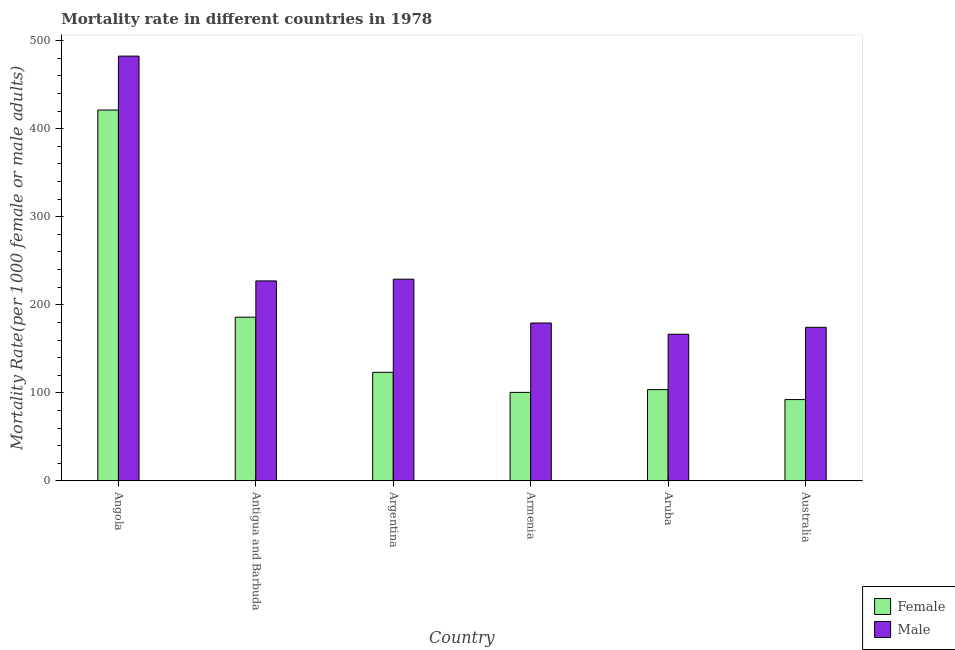Are the number of bars per tick equal to the number of legend labels?
Your response must be concise. Yes. What is the label of the 4th group of bars from the left?
Your response must be concise. Armenia. What is the female mortality rate in Argentina?
Offer a terse response. 123.38. Across all countries, what is the maximum female mortality rate?
Your answer should be compact. 421.19. Across all countries, what is the minimum male mortality rate?
Ensure brevity in your answer.  166.63. In which country was the male mortality rate maximum?
Provide a succinct answer. Angola. In which country was the male mortality rate minimum?
Keep it short and to the point. Aruba. What is the total female mortality rate in the graph?
Make the answer very short. 1027.35. What is the difference between the female mortality rate in Argentina and that in Australia?
Offer a very short reply. 30.94. What is the difference between the male mortality rate in Australia and the female mortality rate in Armenia?
Provide a short and direct response. 73.85. What is the average male mortality rate per country?
Keep it short and to the point. 243.19. What is the difference between the female mortality rate and male mortality rate in Armenia?
Ensure brevity in your answer.  -78.76. What is the ratio of the male mortality rate in Argentina to that in Armenia?
Your response must be concise. 1.28. What is the difference between the highest and the second highest male mortality rate?
Ensure brevity in your answer.  253.26. What is the difference between the highest and the lowest male mortality rate?
Ensure brevity in your answer.  315.75. Is the sum of the female mortality rate in Armenia and Australia greater than the maximum male mortality rate across all countries?
Offer a terse response. No. What does the 2nd bar from the left in Armenia represents?
Give a very brief answer. Male. How many bars are there?
Your answer should be very brief. 12. Are all the bars in the graph horizontal?
Provide a succinct answer. No. How many countries are there in the graph?
Your answer should be very brief. 6. What is the difference between two consecutive major ticks on the Y-axis?
Your response must be concise. 100. Does the graph contain any zero values?
Make the answer very short. No. Where does the legend appear in the graph?
Your answer should be compact. Bottom right. What is the title of the graph?
Make the answer very short. Mortality rate in different countries in 1978. What is the label or title of the Y-axis?
Offer a very short reply. Mortality Rate(per 1000 female or male adults). What is the Mortality Rate(per 1000 female or male adults) of Female in Angola?
Your answer should be very brief. 421.19. What is the Mortality Rate(per 1000 female or male adults) in Male in Angola?
Make the answer very short. 482.38. What is the Mortality Rate(per 1000 female or male adults) of Female in Antigua and Barbuda?
Your answer should be compact. 185.99. What is the Mortality Rate(per 1000 female or male adults) in Male in Antigua and Barbuda?
Make the answer very short. 227.16. What is the Mortality Rate(per 1000 female or male adults) of Female in Argentina?
Your answer should be compact. 123.38. What is the Mortality Rate(per 1000 female or male adults) in Male in Argentina?
Keep it short and to the point. 229.12. What is the Mortality Rate(per 1000 female or male adults) of Female in Armenia?
Provide a short and direct response. 100.61. What is the Mortality Rate(per 1000 female or male adults) of Male in Armenia?
Your answer should be very brief. 179.37. What is the Mortality Rate(per 1000 female or male adults) in Female in Aruba?
Offer a terse response. 103.74. What is the Mortality Rate(per 1000 female or male adults) in Male in Aruba?
Your answer should be very brief. 166.63. What is the Mortality Rate(per 1000 female or male adults) of Female in Australia?
Offer a very short reply. 92.44. What is the Mortality Rate(per 1000 female or male adults) in Male in Australia?
Keep it short and to the point. 174.46. Across all countries, what is the maximum Mortality Rate(per 1000 female or male adults) of Female?
Provide a short and direct response. 421.19. Across all countries, what is the maximum Mortality Rate(per 1000 female or male adults) of Male?
Make the answer very short. 482.38. Across all countries, what is the minimum Mortality Rate(per 1000 female or male adults) of Female?
Keep it short and to the point. 92.44. Across all countries, what is the minimum Mortality Rate(per 1000 female or male adults) of Male?
Your response must be concise. 166.63. What is the total Mortality Rate(per 1000 female or male adults) in Female in the graph?
Your answer should be very brief. 1027.35. What is the total Mortality Rate(per 1000 female or male adults) of Male in the graph?
Keep it short and to the point. 1459.12. What is the difference between the Mortality Rate(per 1000 female or male adults) of Female in Angola and that in Antigua and Barbuda?
Offer a terse response. 235.19. What is the difference between the Mortality Rate(per 1000 female or male adults) of Male in Angola and that in Antigua and Barbuda?
Your answer should be compact. 255.23. What is the difference between the Mortality Rate(per 1000 female or male adults) in Female in Angola and that in Argentina?
Your response must be concise. 297.81. What is the difference between the Mortality Rate(per 1000 female or male adults) of Male in Angola and that in Argentina?
Ensure brevity in your answer.  253.26. What is the difference between the Mortality Rate(per 1000 female or male adults) in Female in Angola and that in Armenia?
Provide a short and direct response. 320.58. What is the difference between the Mortality Rate(per 1000 female or male adults) of Male in Angola and that in Armenia?
Offer a terse response. 303.01. What is the difference between the Mortality Rate(per 1000 female or male adults) of Female in Angola and that in Aruba?
Offer a terse response. 317.45. What is the difference between the Mortality Rate(per 1000 female or male adults) of Male in Angola and that in Aruba?
Your response must be concise. 315.75. What is the difference between the Mortality Rate(per 1000 female or male adults) of Female in Angola and that in Australia?
Offer a terse response. 328.74. What is the difference between the Mortality Rate(per 1000 female or male adults) in Male in Angola and that in Australia?
Your response must be concise. 307.93. What is the difference between the Mortality Rate(per 1000 female or male adults) of Female in Antigua and Barbuda and that in Argentina?
Provide a short and direct response. 62.61. What is the difference between the Mortality Rate(per 1000 female or male adults) in Male in Antigua and Barbuda and that in Argentina?
Your response must be concise. -1.97. What is the difference between the Mortality Rate(per 1000 female or male adults) in Female in Antigua and Barbuda and that in Armenia?
Offer a very short reply. 85.38. What is the difference between the Mortality Rate(per 1000 female or male adults) in Male in Antigua and Barbuda and that in Armenia?
Your response must be concise. 47.78. What is the difference between the Mortality Rate(per 1000 female or male adults) in Female in Antigua and Barbuda and that in Aruba?
Ensure brevity in your answer.  82.25. What is the difference between the Mortality Rate(per 1000 female or male adults) of Male in Antigua and Barbuda and that in Aruba?
Your response must be concise. 60.52. What is the difference between the Mortality Rate(per 1000 female or male adults) of Female in Antigua and Barbuda and that in Australia?
Provide a short and direct response. 93.55. What is the difference between the Mortality Rate(per 1000 female or male adults) in Male in Antigua and Barbuda and that in Australia?
Keep it short and to the point. 52.7. What is the difference between the Mortality Rate(per 1000 female or male adults) of Female in Argentina and that in Armenia?
Ensure brevity in your answer.  22.77. What is the difference between the Mortality Rate(per 1000 female or male adults) of Male in Argentina and that in Armenia?
Give a very brief answer. 49.75. What is the difference between the Mortality Rate(per 1000 female or male adults) in Female in Argentina and that in Aruba?
Keep it short and to the point. 19.64. What is the difference between the Mortality Rate(per 1000 female or male adults) of Male in Argentina and that in Aruba?
Make the answer very short. 62.49. What is the difference between the Mortality Rate(per 1000 female or male adults) of Female in Argentina and that in Australia?
Your answer should be compact. 30.94. What is the difference between the Mortality Rate(per 1000 female or male adults) of Male in Argentina and that in Australia?
Ensure brevity in your answer.  54.66. What is the difference between the Mortality Rate(per 1000 female or male adults) in Female in Armenia and that in Aruba?
Offer a terse response. -3.13. What is the difference between the Mortality Rate(per 1000 female or male adults) in Male in Armenia and that in Aruba?
Provide a succinct answer. 12.74. What is the difference between the Mortality Rate(per 1000 female or male adults) of Female in Armenia and that in Australia?
Make the answer very short. 8.16. What is the difference between the Mortality Rate(per 1000 female or male adults) of Male in Armenia and that in Australia?
Your answer should be very brief. 4.92. What is the difference between the Mortality Rate(per 1000 female or male adults) of Female in Aruba and that in Australia?
Offer a terse response. 11.29. What is the difference between the Mortality Rate(per 1000 female or male adults) of Male in Aruba and that in Australia?
Make the answer very short. -7.82. What is the difference between the Mortality Rate(per 1000 female or male adults) of Female in Angola and the Mortality Rate(per 1000 female or male adults) of Male in Antigua and Barbuda?
Provide a succinct answer. 194.03. What is the difference between the Mortality Rate(per 1000 female or male adults) in Female in Angola and the Mortality Rate(per 1000 female or male adults) in Male in Argentina?
Provide a succinct answer. 192.06. What is the difference between the Mortality Rate(per 1000 female or male adults) in Female in Angola and the Mortality Rate(per 1000 female or male adults) in Male in Armenia?
Offer a very short reply. 241.81. What is the difference between the Mortality Rate(per 1000 female or male adults) of Female in Angola and the Mortality Rate(per 1000 female or male adults) of Male in Aruba?
Give a very brief answer. 254.55. What is the difference between the Mortality Rate(per 1000 female or male adults) of Female in Angola and the Mortality Rate(per 1000 female or male adults) of Male in Australia?
Your response must be concise. 246.73. What is the difference between the Mortality Rate(per 1000 female or male adults) of Female in Antigua and Barbuda and the Mortality Rate(per 1000 female or male adults) of Male in Argentina?
Provide a succinct answer. -43.13. What is the difference between the Mortality Rate(per 1000 female or male adults) of Female in Antigua and Barbuda and the Mortality Rate(per 1000 female or male adults) of Male in Armenia?
Keep it short and to the point. 6.62. What is the difference between the Mortality Rate(per 1000 female or male adults) of Female in Antigua and Barbuda and the Mortality Rate(per 1000 female or male adults) of Male in Aruba?
Keep it short and to the point. 19.36. What is the difference between the Mortality Rate(per 1000 female or male adults) of Female in Antigua and Barbuda and the Mortality Rate(per 1000 female or male adults) of Male in Australia?
Make the answer very short. 11.53. What is the difference between the Mortality Rate(per 1000 female or male adults) in Female in Argentina and the Mortality Rate(per 1000 female or male adults) in Male in Armenia?
Offer a terse response. -55.99. What is the difference between the Mortality Rate(per 1000 female or male adults) of Female in Argentina and the Mortality Rate(per 1000 female or male adults) of Male in Aruba?
Make the answer very short. -43.25. What is the difference between the Mortality Rate(per 1000 female or male adults) in Female in Argentina and the Mortality Rate(per 1000 female or male adults) in Male in Australia?
Give a very brief answer. -51.08. What is the difference between the Mortality Rate(per 1000 female or male adults) of Female in Armenia and the Mortality Rate(per 1000 female or male adults) of Male in Aruba?
Your answer should be compact. -66.02. What is the difference between the Mortality Rate(per 1000 female or male adults) of Female in Armenia and the Mortality Rate(per 1000 female or male adults) of Male in Australia?
Give a very brief answer. -73.85. What is the difference between the Mortality Rate(per 1000 female or male adults) in Female in Aruba and the Mortality Rate(per 1000 female or male adults) in Male in Australia?
Your answer should be compact. -70.72. What is the average Mortality Rate(per 1000 female or male adults) of Female per country?
Ensure brevity in your answer.  171.23. What is the average Mortality Rate(per 1000 female or male adults) in Male per country?
Your answer should be very brief. 243.19. What is the difference between the Mortality Rate(per 1000 female or male adults) in Female and Mortality Rate(per 1000 female or male adults) in Male in Angola?
Provide a short and direct response. -61.2. What is the difference between the Mortality Rate(per 1000 female or male adults) in Female and Mortality Rate(per 1000 female or male adults) in Male in Antigua and Barbuda?
Make the answer very short. -41.16. What is the difference between the Mortality Rate(per 1000 female or male adults) in Female and Mortality Rate(per 1000 female or male adults) in Male in Argentina?
Offer a very short reply. -105.74. What is the difference between the Mortality Rate(per 1000 female or male adults) of Female and Mortality Rate(per 1000 female or male adults) of Male in Armenia?
Offer a very short reply. -78.76. What is the difference between the Mortality Rate(per 1000 female or male adults) of Female and Mortality Rate(per 1000 female or male adults) of Male in Aruba?
Your answer should be very brief. -62.89. What is the difference between the Mortality Rate(per 1000 female or male adults) of Female and Mortality Rate(per 1000 female or male adults) of Male in Australia?
Provide a succinct answer. -82.01. What is the ratio of the Mortality Rate(per 1000 female or male adults) in Female in Angola to that in Antigua and Barbuda?
Your answer should be very brief. 2.26. What is the ratio of the Mortality Rate(per 1000 female or male adults) in Male in Angola to that in Antigua and Barbuda?
Provide a succinct answer. 2.12. What is the ratio of the Mortality Rate(per 1000 female or male adults) in Female in Angola to that in Argentina?
Keep it short and to the point. 3.41. What is the ratio of the Mortality Rate(per 1000 female or male adults) in Male in Angola to that in Argentina?
Your response must be concise. 2.11. What is the ratio of the Mortality Rate(per 1000 female or male adults) in Female in Angola to that in Armenia?
Offer a very short reply. 4.19. What is the ratio of the Mortality Rate(per 1000 female or male adults) of Male in Angola to that in Armenia?
Give a very brief answer. 2.69. What is the ratio of the Mortality Rate(per 1000 female or male adults) of Female in Angola to that in Aruba?
Keep it short and to the point. 4.06. What is the ratio of the Mortality Rate(per 1000 female or male adults) in Male in Angola to that in Aruba?
Offer a terse response. 2.89. What is the ratio of the Mortality Rate(per 1000 female or male adults) in Female in Angola to that in Australia?
Offer a very short reply. 4.56. What is the ratio of the Mortality Rate(per 1000 female or male adults) of Male in Angola to that in Australia?
Provide a short and direct response. 2.77. What is the ratio of the Mortality Rate(per 1000 female or male adults) in Female in Antigua and Barbuda to that in Argentina?
Provide a short and direct response. 1.51. What is the ratio of the Mortality Rate(per 1000 female or male adults) in Female in Antigua and Barbuda to that in Armenia?
Your response must be concise. 1.85. What is the ratio of the Mortality Rate(per 1000 female or male adults) in Male in Antigua and Barbuda to that in Armenia?
Offer a very short reply. 1.27. What is the ratio of the Mortality Rate(per 1000 female or male adults) of Female in Antigua and Barbuda to that in Aruba?
Make the answer very short. 1.79. What is the ratio of the Mortality Rate(per 1000 female or male adults) in Male in Antigua and Barbuda to that in Aruba?
Provide a short and direct response. 1.36. What is the ratio of the Mortality Rate(per 1000 female or male adults) of Female in Antigua and Barbuda to that in Australia?
Give a very brief answer. 2.01. What is the ratio of the Mortality Rate(per 1000 female or male adults) of Male in Antigua and Barbuda to that in Australia?
Provide a succinct answer. 1.3. What is the ratio of the Mortality Rate(per 1000 female or male adults) of Female in Argentina to that in Armenia?
Provide a short and direct response. 1.23. What is the ratio of the Mortality Rate(per 1000 female or male adults) in Male in Argentina to that in Armenia?
Keep it short and to the point. 1.28. What is the ratio of the Mortality Rate(per 1000 female or male adults) in Female in Argentina to that in Aruba?
Provide a short and direct response. 1.19. What is the ratio of the Mortality Rate(per 1000 female or male adults) of Male in Argentina to that in Aruba?
Your answer should be very brief. 1.38. What is the ratio of the Mortality Rate(per 1000 female or male adults) of Female in Argentina to that in Australia?
Offer a terse response. 1.33. What is the ratio of the Mortality Rate(per 1000 female or male adults) of Male in Argentina to that in Australia?
Offer a terse response. 1.31. What is the ratio of the Mortality Rate(per 1000 female or male adults) of Female in Armenia to that in Aruba?
Your answer should be very brief. 0.97. What is the ratio of the Mortality Rate(per 1000 female or male adults) of Male in Armenia to that in Aruba?
Make the answer very short. 1.08. What is the ratio of the Mortality Rate(per 1000 female or male adults) of Female in Armenia to that in Australia?
Your response must be concise. 1.09. What is the ratio of the Mortality Rate(per 1000 female or male adults) of Male in Armenia to that in Australia?
Ensure brevity in your answer.  1.03. What is the ratio of the Mortality Rate(per 1000 female or male adults) of Female in Aruba to that in Australia?
Keep it short and to the point. 1.12. What is the ratio of the Mortality Rate(per 1000 female or male adults) of Male in Aruba to that in Australia?
Your answer should be very brief. 0.96. What is the difference between the highest and the second highest Mortality Rate(per 1000 female or male adults) in Female?
Your answer should be compact. 235.19. What is the difference between the highest and the second highest Mortality Rate(per 1000 female or male adults) in Male?
Your answer should be compact. 253.26. What is the difference between the highest and the lowest Mortality Rate(per 1000 female or male adults) in Female?
Provide a short and direct response. 328.74. What is the difference between the highest and the lowest Mortality Rate(per 1000 female or male adults) in Male?
Offer a terse response. 315.75. 